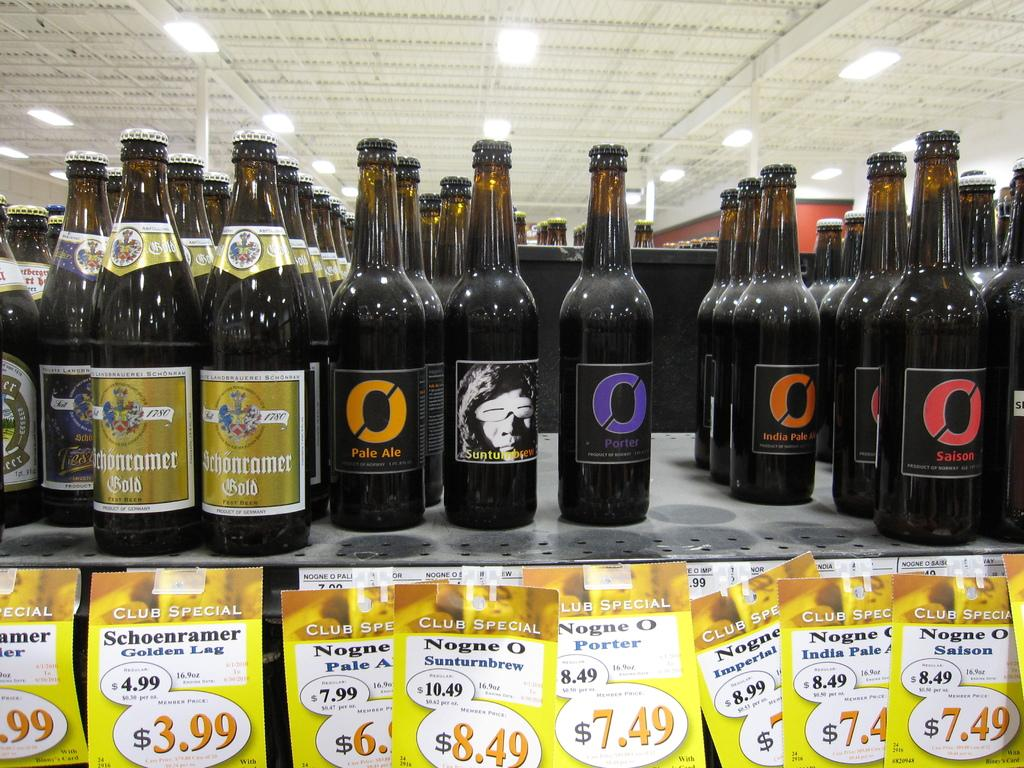<image>
Write a terse but informative summary of the picture. Bottles of pale ale are lined up with other bottles. 